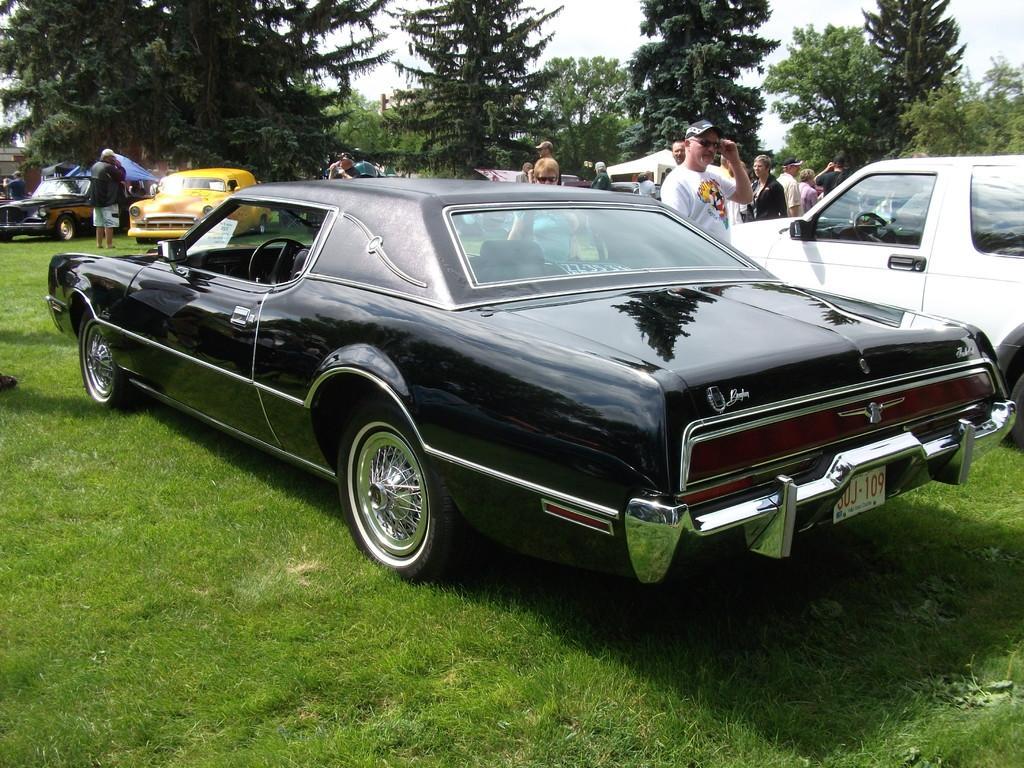Describe this image in one or two sentences. In the image I can see some cars and people on the grass and also I can see some trees to the side. 